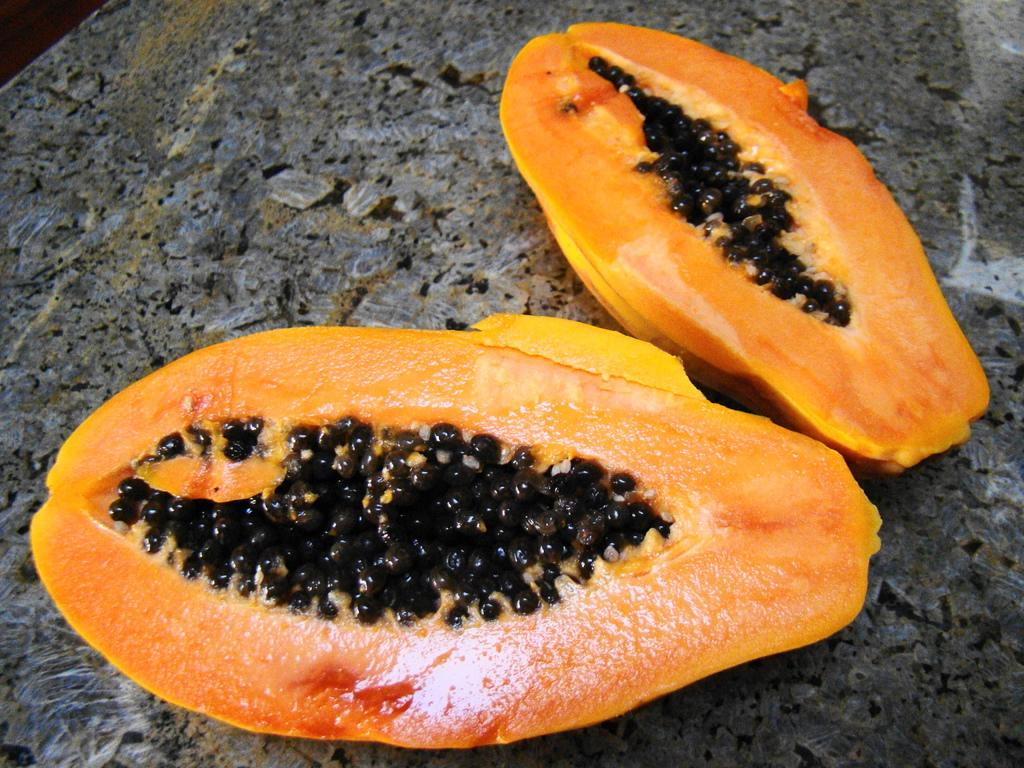What type of fruit is in the image? There is a papaya in the image. How is the papaya divided in the image? The papaya is divided into two equal halves. Where are the papaya halves located? The papaya halves are on a table. What can be seen inside the papaya halves? There are seeds visible in the image. How many kittens are playing with the unit of the idea in the image? There are no kittens or units of ideas present in the image; it features a papaya divided into two halves on a table. 